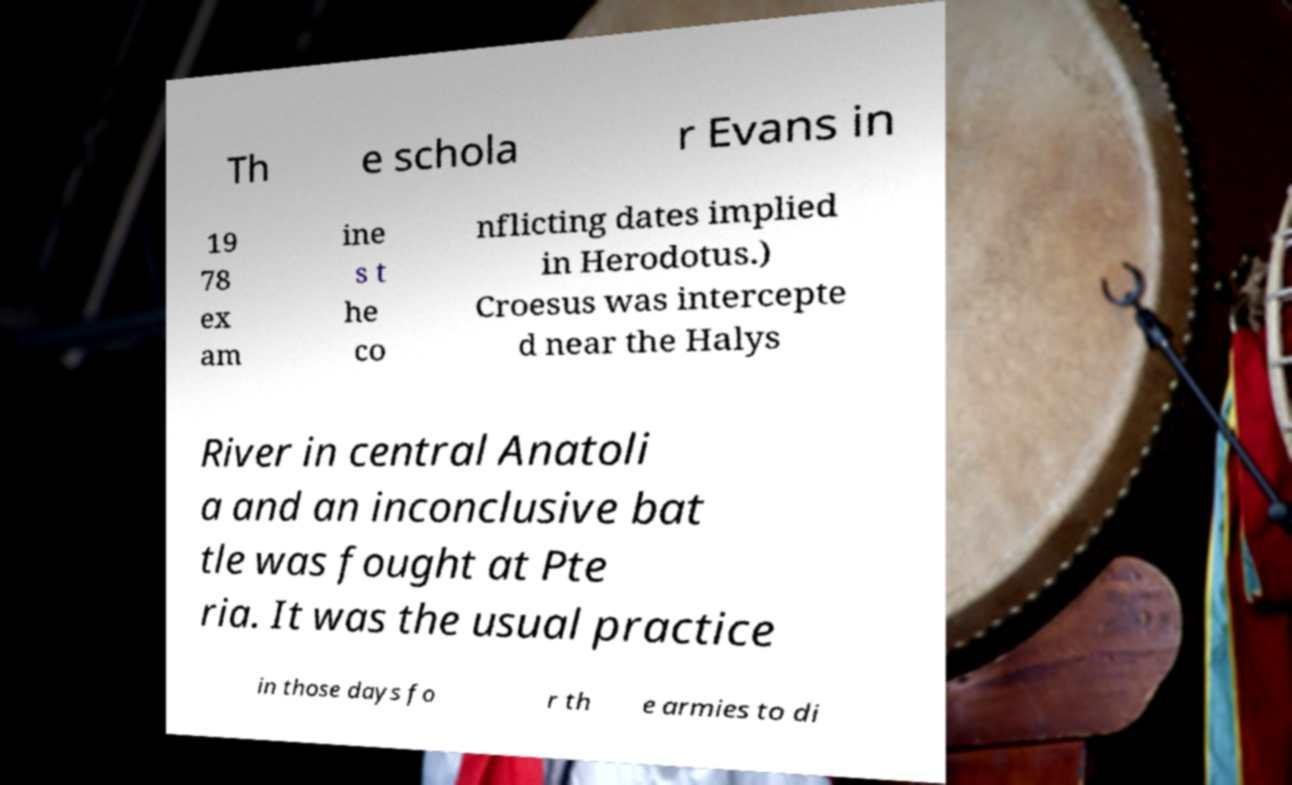Can you read and provide the text displayed in the image?This photo seems to have some interesting text. Can you extract and type it out for me? Th e schola r Evans in 19 78 ex am ine s t he co nflicting dates implied in Herodotus.) Croesus was intercepte d near the Halys River in central Anatoli a and an inconclusive bat tle was fought at Pte ria. It was the usual practice in those days fo r th e armies to di 